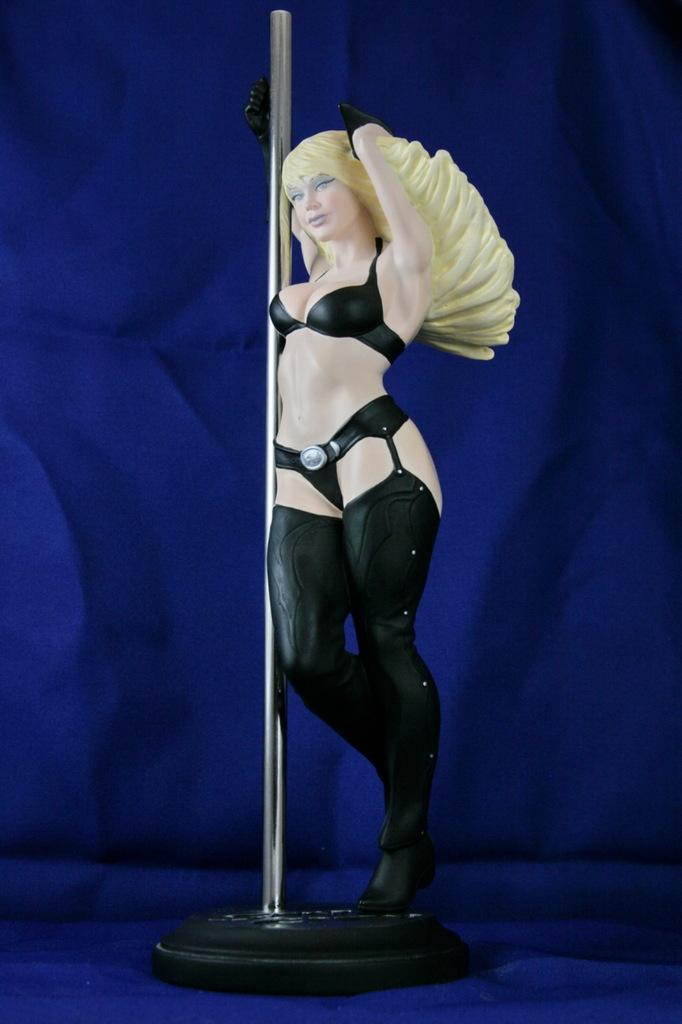What type of object is in the image? There is a toy of a person in the image. What is the toy person doing in the image? The toy person is standing and holding a pole. What color is the background of the image? The background of the image is blue. How many chickens are visible in the image? There are no chickens present in the image. What is the rate of snowfall in the image? There is no snowfall present in the image. 